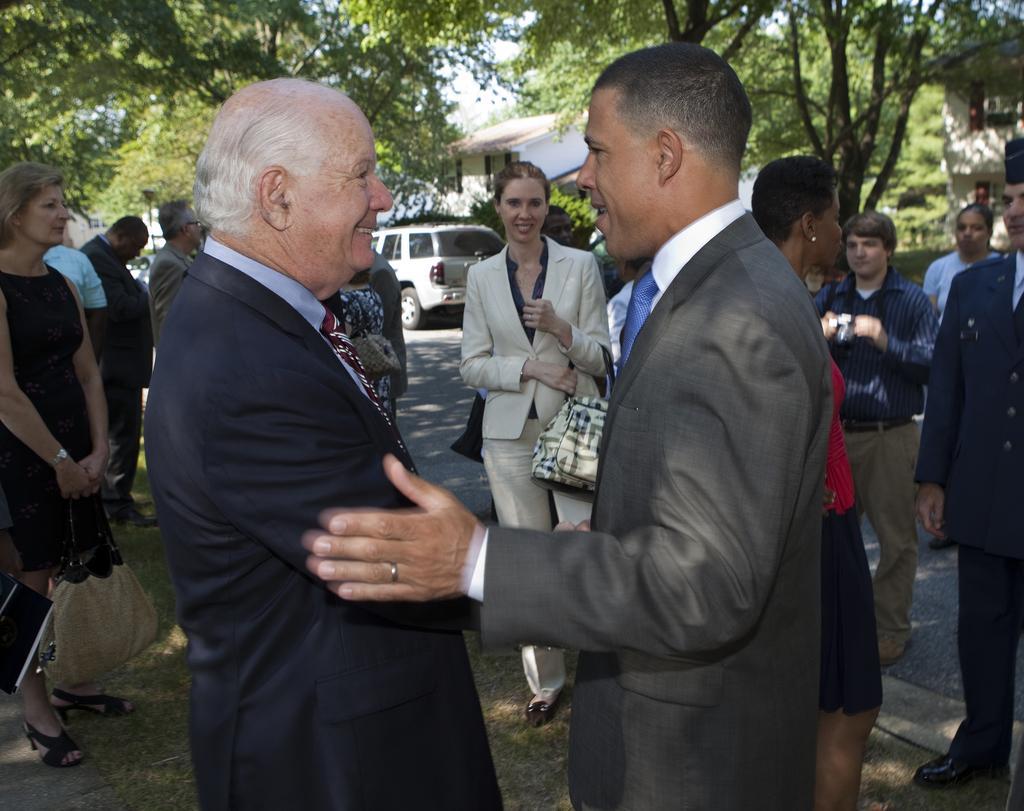Please provide a concise description of this image. In this image there is the sky towards the top of the image, there are trees towards the top of the image, there is a building towards the right of the image, there is a road, there is a vehicle on the road, there are a group of persons standing, they are holding an object, there is grass towards the bottom of the image. 